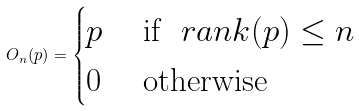<formula> <loc_0><loc_0><loc_500><loc_500>O _ { n } ( p ) = \begin{cases} p & \text { if } \ r a n k ( p ) \leq n \\ 0 & \text { otherwise} \end{cases}</formula> 